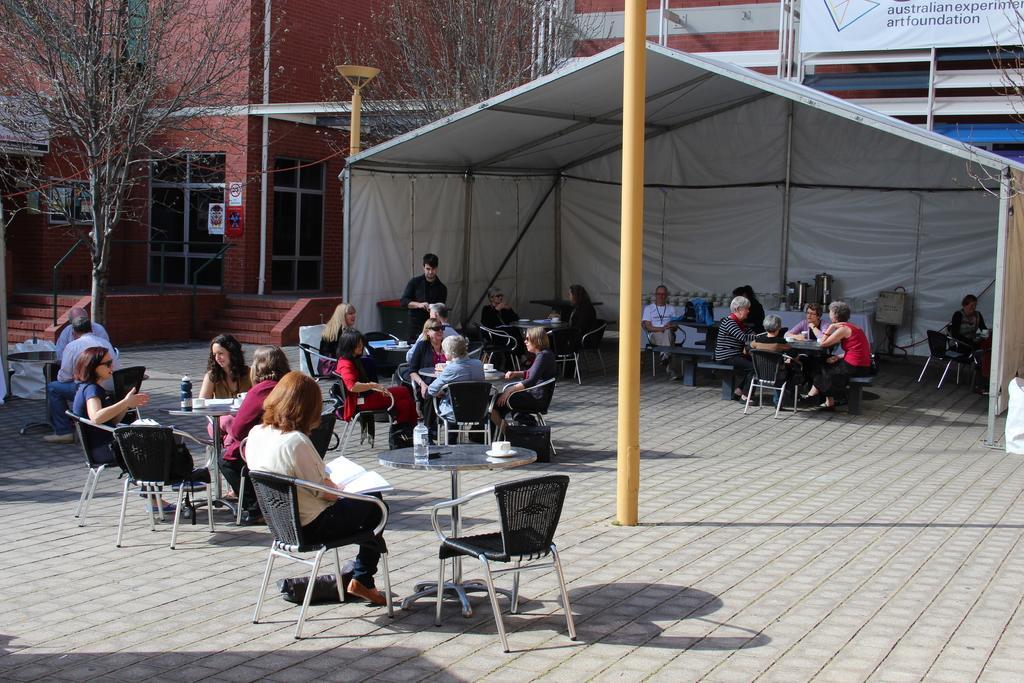Describe this image in one or two sentences. In the middle of the image this man is standing. In the middle of the image these people are sitting on a chair. In the middle of the image there is a table, On the table there is a water bottle and a cup and a saucer. In the middle of the image there is a pole. Top right side of the image there is a tent. Top left side of the image there is a tree. Behind the tree there is a building. 